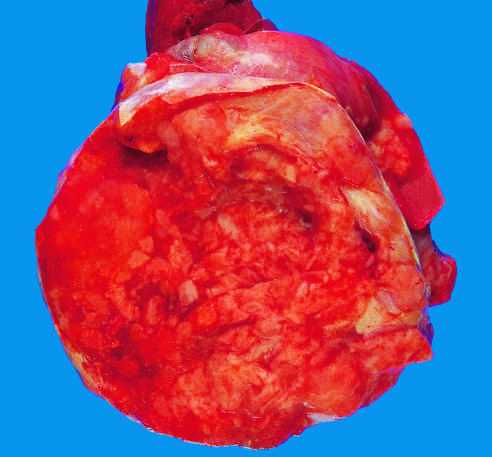re the internal and external elastic membranes large and hyperchromatic?
Answer the question using a single word or phrase. No 